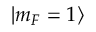<formula> <loc_0><loc_0><loc_500><loc_500>| m _ { F } = 1 \rangle</formula> 